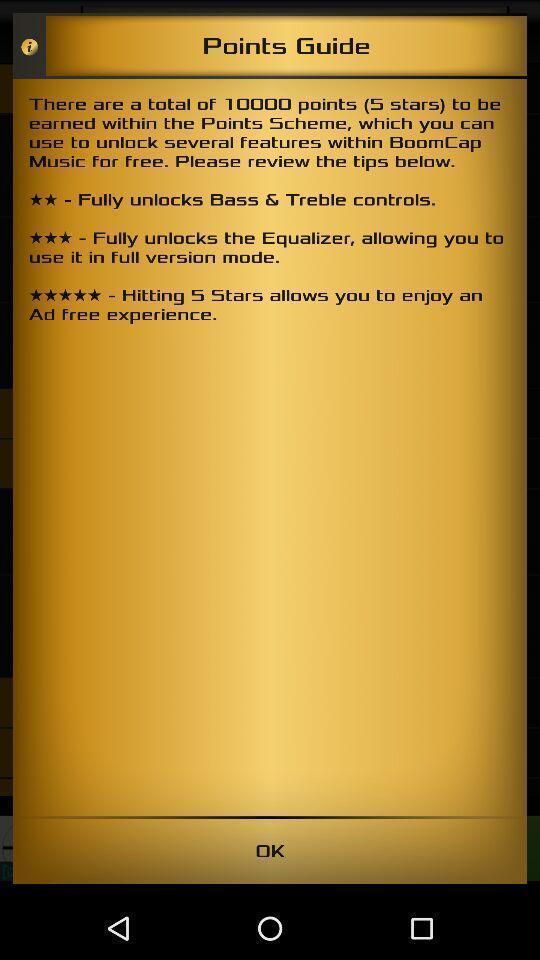What can you discern from this picture? Social app for the guide. 